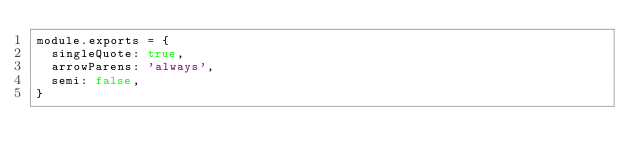Convert code to text. <code><loc_0><loc_0><loc_500><loc_500><_JavaScript_>module.exports = {
  singleQuote: true,
  arrowParens: 'always',
  semi: false,
}
</code> 